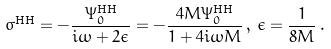<formula> <loc_0><loc_0><loc_500><loc_500>\sigma ^ { \text {HH} } = - \frac { \Psi _ { 0 } ^ { \text {HH} } } { i \omega + 2 \epsilon } = - \frac { 4 M \Psi _ { 0 } ^ { \text {HH} } } { 1 + 4 i \omega M } \, , \, \epsilon = \frac { 1 } { 8 M } \, .</formula> 